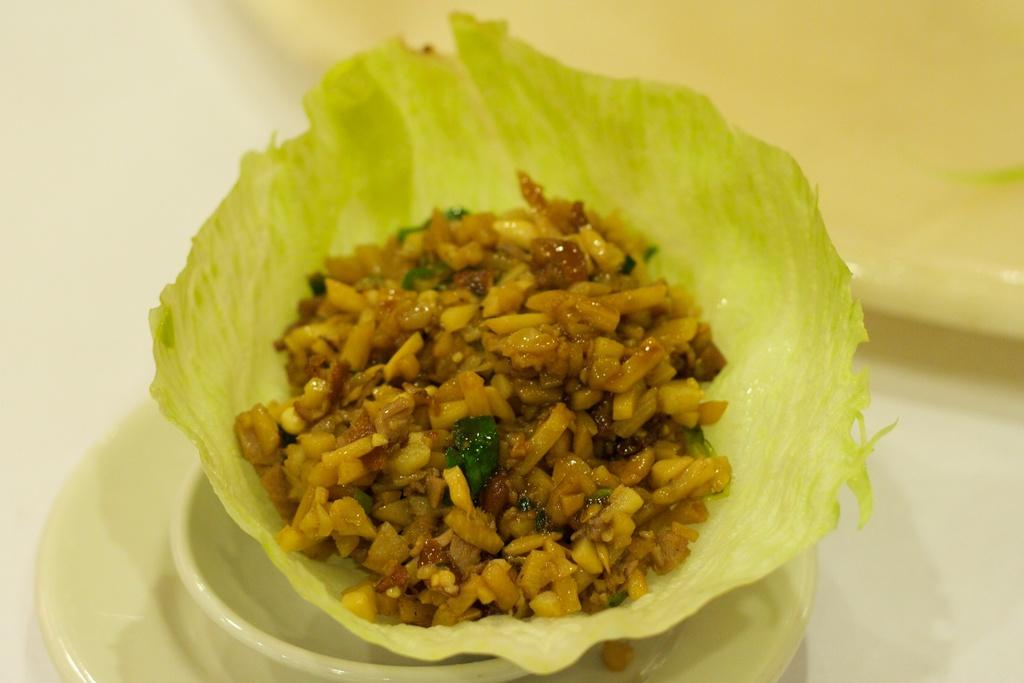What is located on the plate in the image? There is a bowl on a plate in the image. What can be found in the middle of the image? There is food in the middle of the image. What type of copper material is used to make the bag in the image? There is no bag or copper material present in the image. 